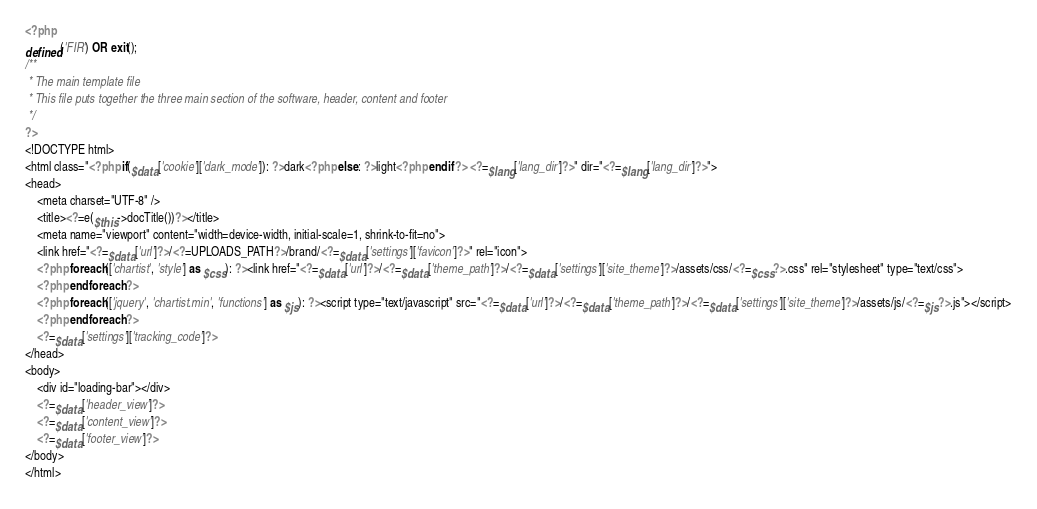<code> <loc_0><loc_0><loc_500><loc_500><_PHP_><?php
defined('FIR') OR exit();
/**
 * The main template file
 * This file puts together the three main section of the software, header, content and footer
 */
?>
<!DOCTYPE html>
<html class="<?php if($data['cookie']['dark_mode']): ?>dark<?php else: ?>light<?php endif ?> <?=$lang['lang_dir']?>" dir="<?=$lang['lang_dir']?>">
<head>
    <meta charset="UTF-8" />
    <title><?=e($this->docTitle())?></title>
    <meta name="viewport" content="width=device-width, initial-scale=1, shrink-to-fit=no">
    <link href="<?=$data['url']?>/<?=UPLOADS_PATH?>/brand/<?=$data['settings']['favicon']?>" rel="icon">
    <?php foreach(['chartist', 'style'] as $css): ?><link href="<?=$data['url']?>/<?=$data['theme_path']?>/<?=$data['settings']['site_theme']?>/assets/css/<?=$css?>.css" rel="stylesheet" type="text/css">
    <?php endforeach ?>
    <?php foreach(['jquery', 'chartist.min', 'functions'] as $js): ?><script type="text/javascript" src="<?=$data['url']?>/<?=$data['theme_path']?>/<?=$data['settings']['site_theme']?>/assets/js/<?=$js?>.js"></script>
    <?php endforeach ?>
    <?=$data['settings']['tracking_code']?>
</head>
<body>
    <div id="loading-bar"></div>
    <?=$data['header_view']?>
    <?=$data['content_view']?>
    <?=$data['footer_view']?>
</body>
</html></code> 